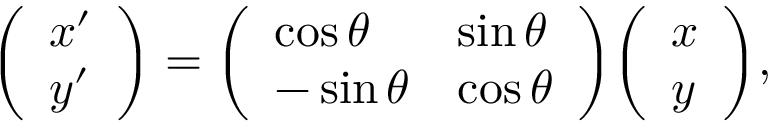<formula> <loc_0><loc_0><loc_500><loc_500>{ \left ( \begin{array} { l } { x ^ { \prime } } \\ { y ^ { \prime } } \end{array} \right ) } = { \left ( \begin{array} { l l } { \cos \theta } & { \sin \theta } \\ { - \sin \theta } & { \cos \theta } \end{array} \right ) } { \left ( \begin{array} { l } { x } \\ { y } \end{array} \right ) } ,</formula> 